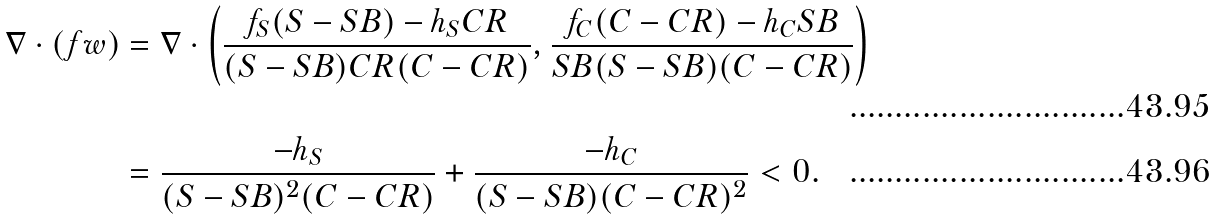Convert formula to latex. <formula><loc_0><loc_0><loc_500><loc_500>\nabla \cdot \left ( f w \right ) & = \nabla \cdot \left ( \frac { f _ { S } ( S - S B ) - h _ { S } C R } { ( S - S B ) C R ( C - C R ) } , \frac { f _ { C } ( C - C R ) - h _ { C } S B } { S B ( S - S B ) ( C - C R ) } \right ) \\ & = \frac { - h _ { S } } { ( S - S B ) ^ { 2 } ( C - C R ) } + \frac { - h _ { C } } { ( S - S B ) ( C - C R ) ^ { 2 } } < 0 .</formula> 